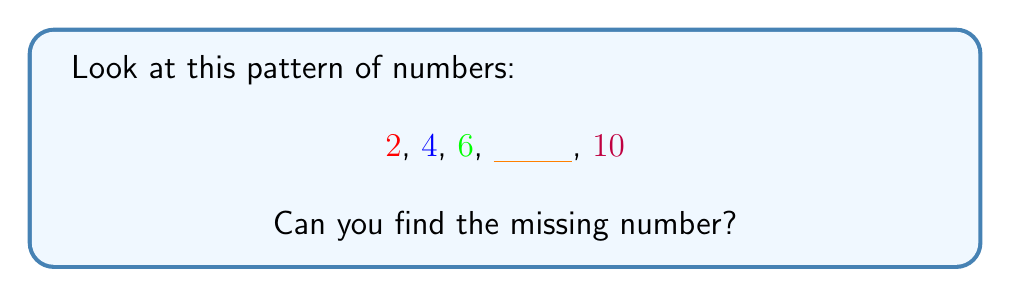Help me with this question. Let's look at this pattern step by step:

1. We start with 2
2. Then we have 4
3. Next is 6
4. There's a blank space
5. The last number is 10

To find the missing number, we need to see how the numbers are changing:

- From 2 to 4, we add 2
- From 4 to 6, we add 2 again
- From 6 to the missing number, we should add 2
- From the missing number to 10, we should add 2

So, if we add 2 to 6, we get 8. This is our missing number!

We can check:
2 + 2 = 4
4 + 2 = 6
6 + 2 = 8 (our missing number)
8 + 2 = 10

The pattern is adding 2 each time, which gives us:

$2, 4, 6, 8, 10$
Answer: 8 